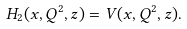Convert formula to latex. <formula><loc_0><loc_0><loc_500><loc_500>H _ { 2 } ( x , Q ^ { 2 } , z ) = V ( x , Q ^ { 2 } , z ) .</formula> 